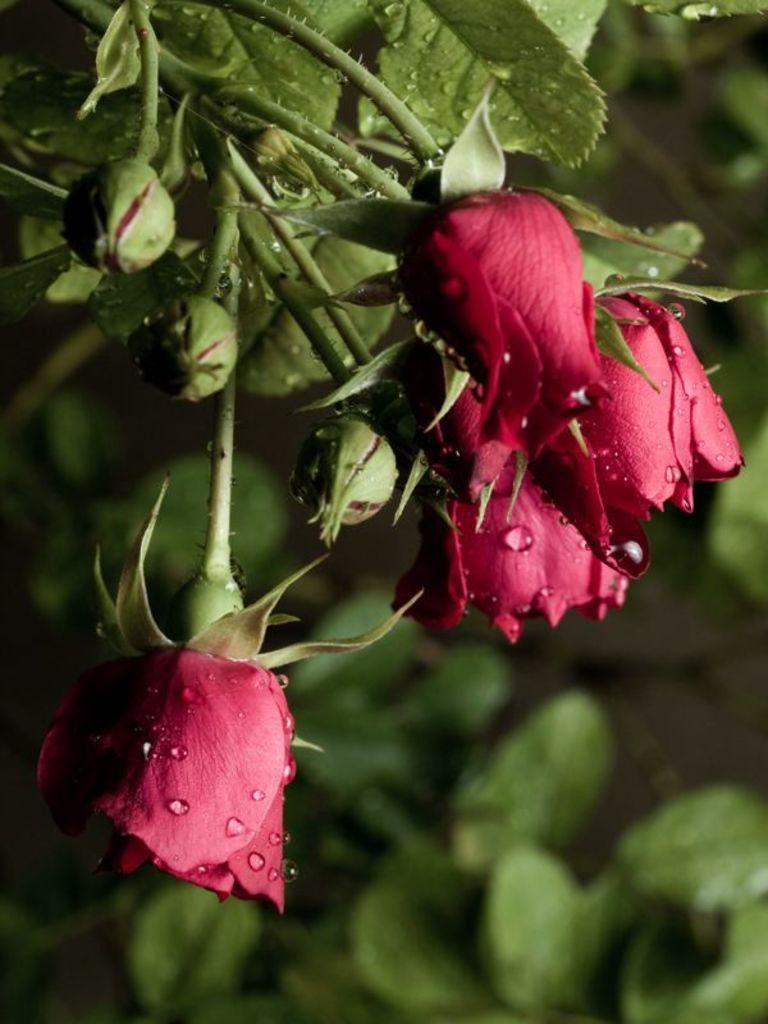What type of plants can be seen in the image? There are flowers, buds, and leaves in the image. Can you describe the stage of growth for the plants in the image? The image shows both flowers and buds, indicating that some plants are in bloom while others are still growing. What is the background of the image like? The background of the image is blurred. What hobbies do the children in the image enjoy? There are no children present in the image; it features plants with flowers, buds, and leaves. How does the brother in the image interact with the plants? There is no brother present in the image; it features plants with flowers, buds, and leaves. 